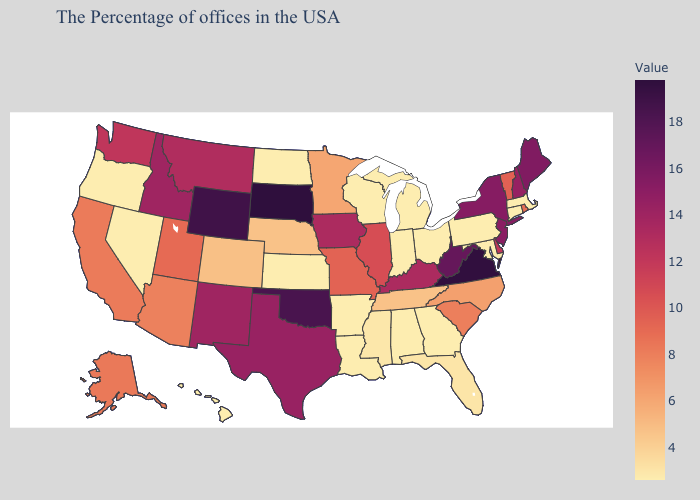Does Nebraska have a lower value than Kentucky?
Keep it brief. Yes. Does Montana have a lower value than New Jersey?
Quick response, please. Yes. Which states have the lowest value in the Northeast?
Answer briefly. Massachusetts, Connecticut, Pennsylvania. Does South Dakota have the highest value in the USA?
Short answer required. Yes. Which states have the lowest value in the Northeast?
Short answer required. Massachusetts, Connecticut, Pennsylvania. Does Idaho have the lowest value in the West?
Give a very brief answer. No. 